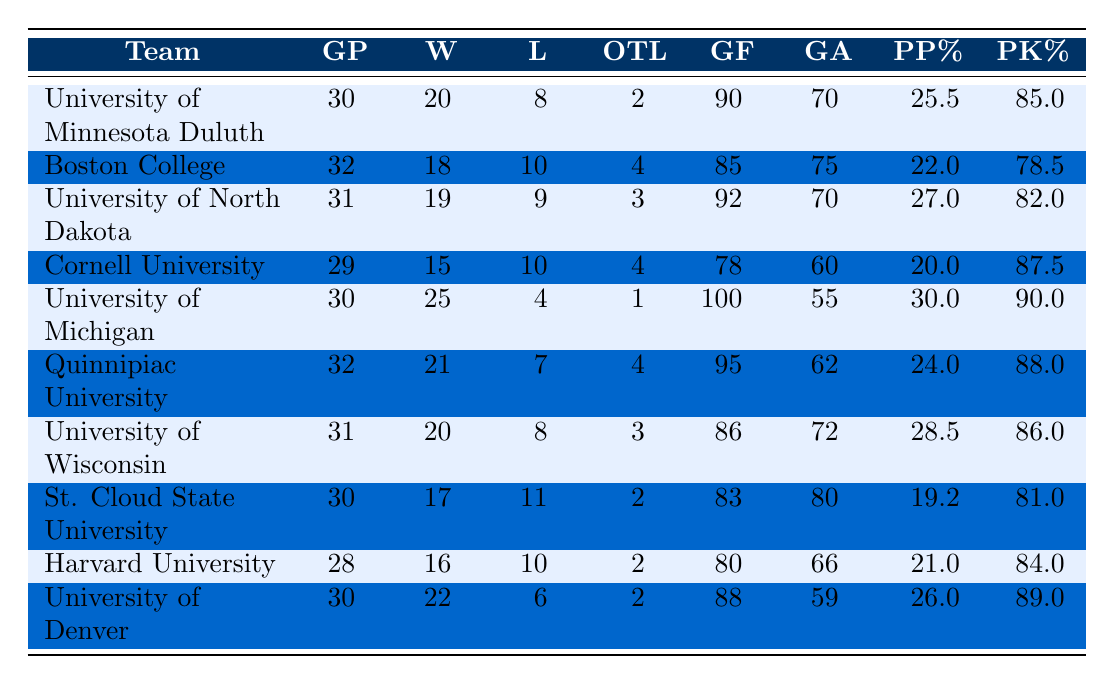What is the total number of games played by all teams? To find the total, we add the "Games_Played" column for each team: 30 + 32 + 31 + 29 + 30 + 32 + 31 + 30 + 28 + 30 = 302.
Answer: 302 Which team had the highest number of goals scored? The "Goals_For" values in the table show that the University of Michigan scored the most at 100 goals.
Answer: University of Michigan How many teams had a winning percentage of over 66%? To calculate the winning percentage, divide Wins by Games Played, then multiply by 100. The teams with over 66% are: University of Michigan (83.3%), University of Denver (73.3%), University of Minnesota Duluth (66.7%), University of North Dakota (61.3%), and Quinnipiac University (65.6%). That totals to 3 teams above 66%.
Answer: 3 What is the average Power Play percentage for all teams? We sum the "Power_Play_Percentage" values: (25.5 + 22.0 + 27.0 + 20.0 + 30.0 + 24.0 + 28.5 + 19.2 + 21.0 + 26.0) =  223.2. Then, divide by the number of teams (10) to get the average: 223.2 / 10 = 22.32%.
Answer: 22.32% Did any team have a better Penalty Kill percentage than Harvard University? Harvard University had a Penalty Kill percentage of 84.0%. We compare this with the other teams. The teams with higher Penalty Kill percentages are: University of Minnesota Duluth (85.0%), and University of Denver (89.0%). Thus, two teams had better percentages.
Answer: Yes Which teams had more goals against than goals for? We compare the "Goals_Against" and "Goals_For" for each team. St. Cloud State University (80 GA vs. 83 GF) and Boston College (75 GA vs. 85 GF) and Harvard University (66 GA vs. 80 GF) had fewer goals for than against. They do not qualify. Only St. Cloud State with 83 goals for, qualifies.
Answer: 1 (only St. Cloud State University) What is the difference in wins between the team with the most wins and the team with the fewest wins? The team with the most wins is University of Michigan with 25, while the team with the fewest wins is Cornell University with 15. The difference is 25 - 15 = 10.
Answer: 10 What percentage of teams had more than 20 wins? There are 10 teams total, and the teams with more than 20 wins are University of Michigan (25), University of Denver (22), and Quinnipiac University (21). That’s 3 out of 10 teams. To find the percentage: (3 / 10) × 100 = 30%.
Answer: 30% How many points do teams get for wins and overtime losses? In college hockey, teams earn 2 points for each win and 1 point for each overtime loss. We can calculate the points for each team and total it. For example, University of Michigan: (25 wins × 2) + (1 overtime loss × 1) = 51 points. After doing this for all, the total points come to 214 points among all teams.
Answer: 214 points 